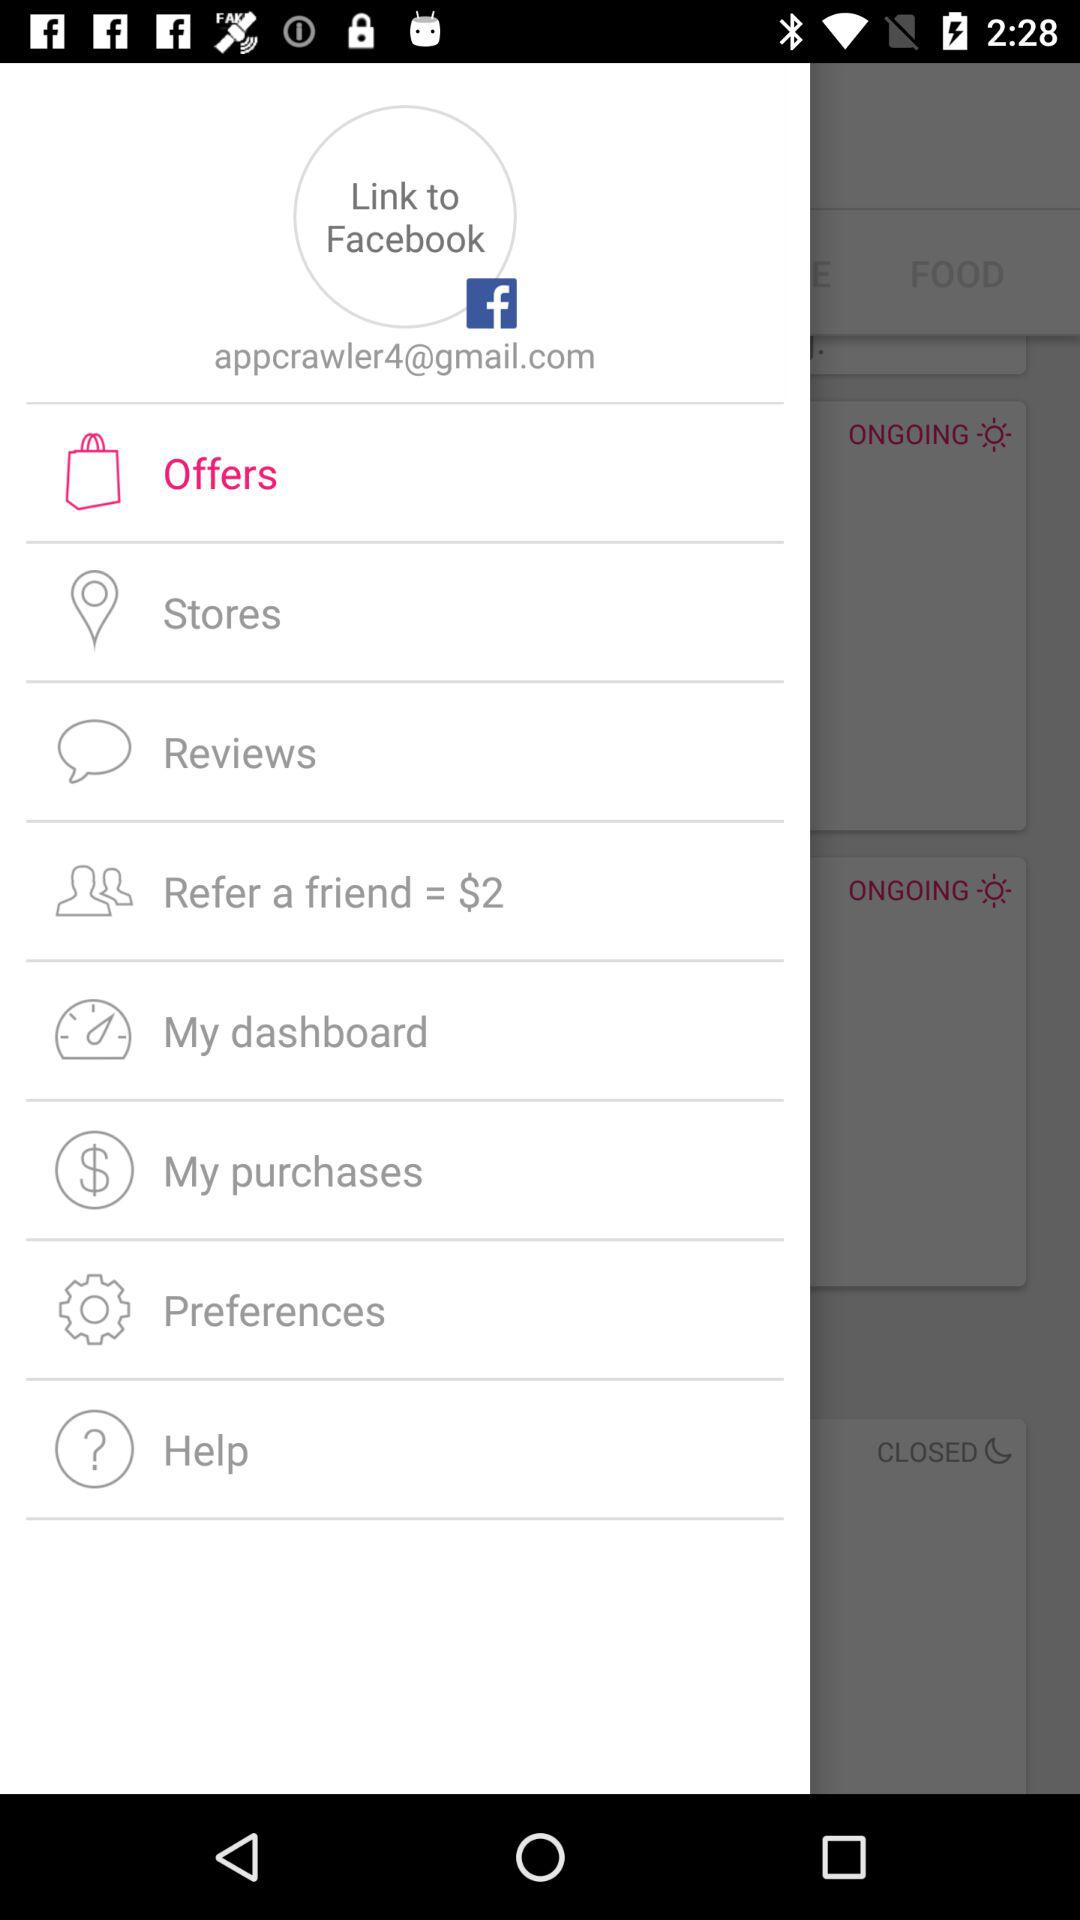What is the given email address? The given email address is appcrawler4@gmail.com. 